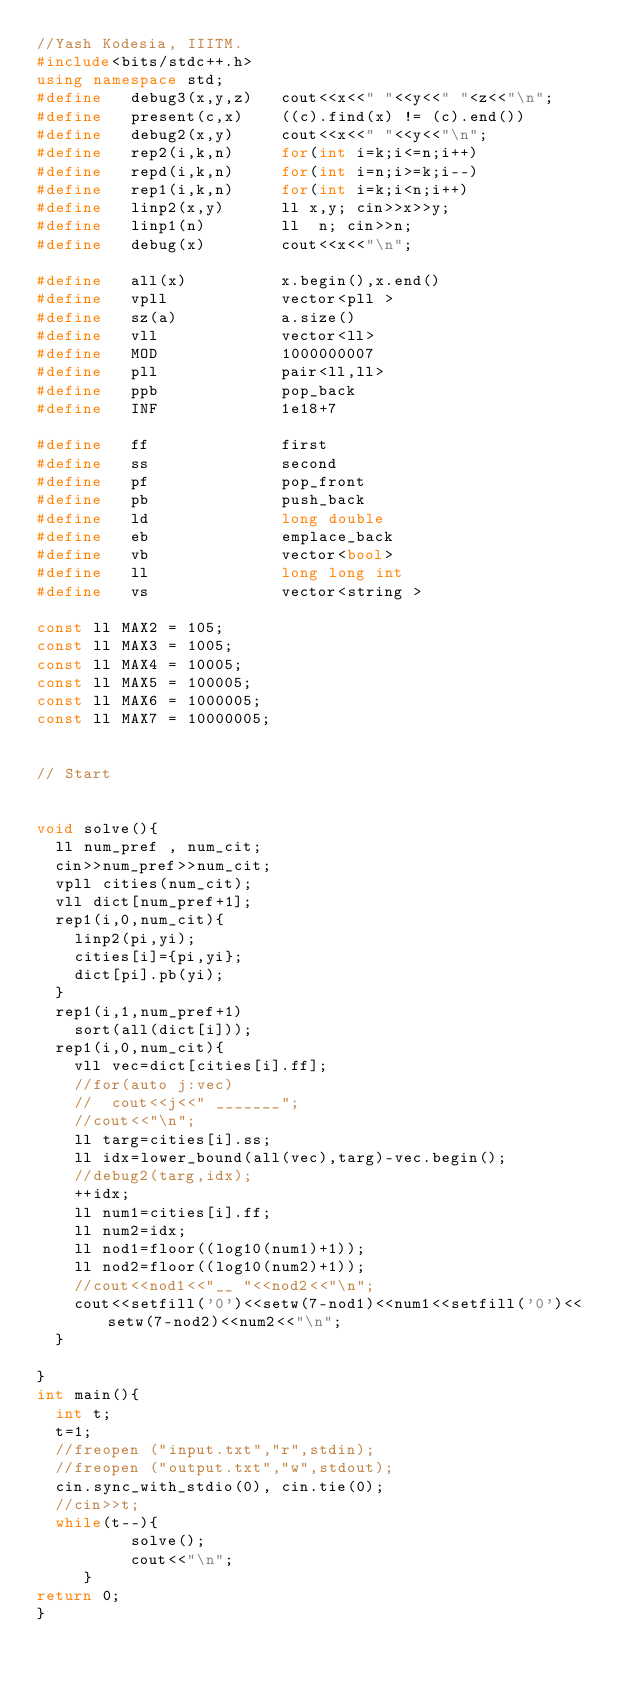Convert code to text. <code><loc_0><loc_0><loc_500><loc_500><_C++_>//Yash Kodesia, IIITM.
#include<bits/stdc++.h>
using namespace std;
#define   debug3(x,y,z)   cout<<x<<" "<<y<<" "<z<<"\n";
#define   present(c,x)    ((c).find(x) != (c).end())
#define   debug2(x,y)     cout<<x<<" "<<y<<"\n";
#define   rep2(i,k,n)     for(int i=k;i<=n;i++)
#define   repd(i,k,n)     for(int i=n;i>=k;i--)
#define   rep1(i,k,n)     for(int i=k;i<n;i++)
#define   linp2(x,y)      ll x,y; cin>>x>>y;
#define   linp1(n)        ll  n; cin>>n;
#define   debug(x)        cout<<x<<"\n";

#define   all(x)          x.begin(),x.end()
#define   vpll            vector<pll >
#define   sz(a)           a.size()
#define   vll             vector<ll>
#define   MOD             1000000007
#define   pll             pair<ll,ll>
#define   ppb             pop_back
#define   INF             1e18+7

#define   ff              first
#define   ss              second
#define   pf              pop_front
#define   pb              push_back
#define   ld              long double
#define   eb              emplace_back
#define   vb              vector<bool>
#define   ll              long long int
#define   vs              vector<string > 

const ll MAX2 = 105;
const ll MAX3 = 1005;
const ll MAX4 = 10005;
const ll MAX5 = 100005;
const ll MAX6 = 1000005;
const ll MAX7 = 10000005;


// Start
 
 
void solve(){
	ll num_pref , num_cit;
	cin>>num_pref>>num_cit;
	vpll cities(num_cit);
	vll dict[num_pref+1];
	rep1(i,0,num_cit){
		linp2(pi,yi);
		cities[i]={pi,yi};
		dict[pi].pb(yi);
	}
	rep1(i,1,num_pref+1)
		sort(all(dict[i]));
	rep1(i,0,num_cit){
		vll vec=dict[cities[i].ff];
		//for(auto j:vec)
		//	cout<<j<<" _______";
		//cout<<"\n";
		ll targ=cities[i].ss;
		ll idx=lower_bound(all(vec),targ)-vec.begin();
		//debug2(targ,idx);
		++idx;
		ll num1=cities[i].ff;
		ll num2=idx;
		ll nod1=floor((log10(num1)+1));
		ll nod2=floor((log10(num2)+1));
		//cout<<nod1<<"__ "<<nod2<<"\n";
		cout<<setfill('0')<<setw(7-nod1)<<num1<<setfill('0')<<setw(7-nod2)<<num2<<"\n";
	}
  
}
int main(){
  int t;
  t=1;
  //freopen ("input.txt","r",stdin);
  //freopen ("output.txt","w",stdout);
  cin.sync_with_stdio(0), cin.tie(0);
  //cin>>t;
  while(t--){
          solve();
          cout<<"\n";
     }
return 0;
}
 </code> 